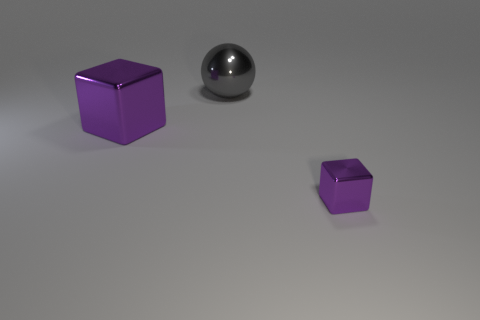Add 1 yellow shiny spheres. How many objects exist? 4 Subtract all spheres. How many objects are left? 2 Add 1 big gray objects. How many big gray objects exist? 2 Subtract 0 gray cylinders. How many objects are left? 3 Subtract all purple shiny cubes. Subtract all small purple metal things. How many objects are left? 0 Add 2 purple shiny cubes. How many purple shiny cubes are left? 4 